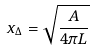Convert formula to latex. <formula><loc_0><loc_0><loc_500><loc_500>x _ { \Delta } = \sqrt { \frac { A } { 4 \pi L } }</formula> 